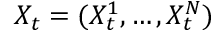Convert formula to latex. <formula><loc_0><loc_0><loc_500><loc_500>X _ { t } = ( X _ { t } ^ { 1 } , \dots , X _ { t } ^ { N } )</formula> 